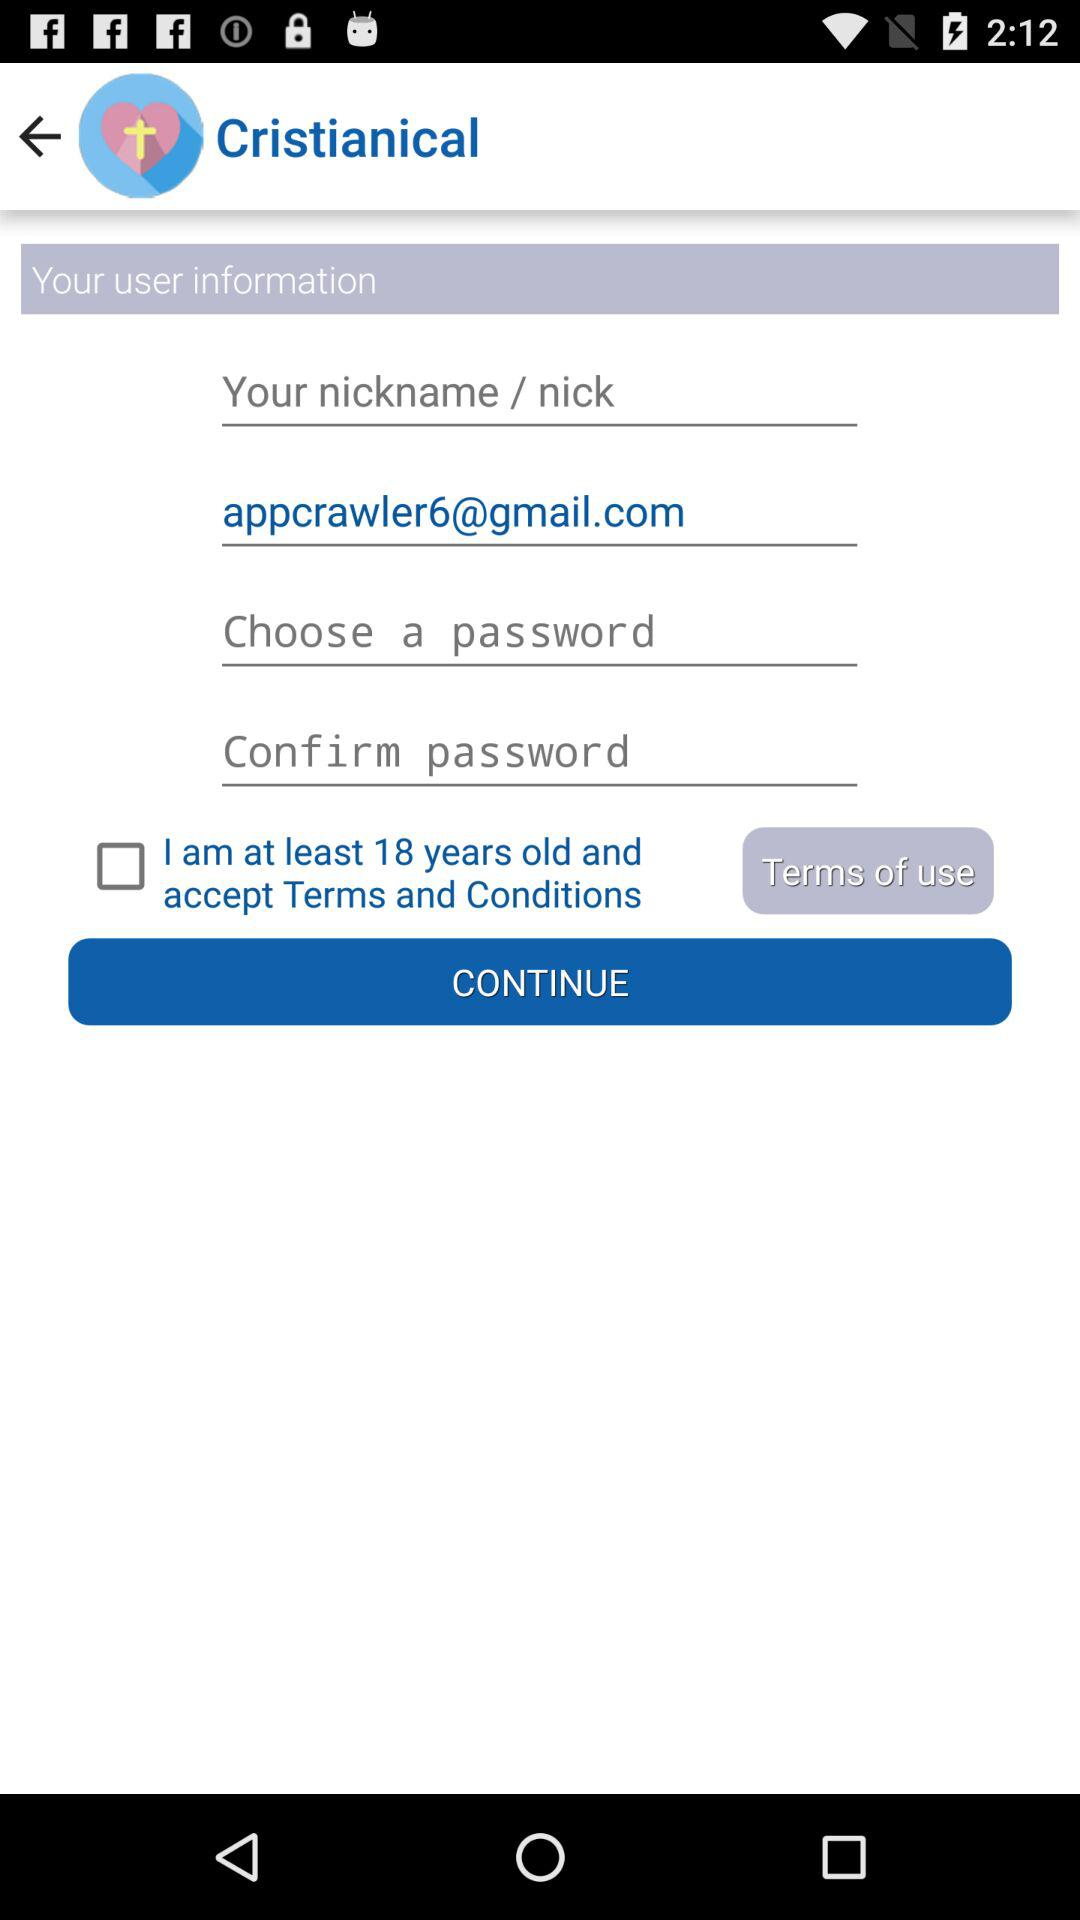What is the name of the application? The name of the application is "Cristianical". 